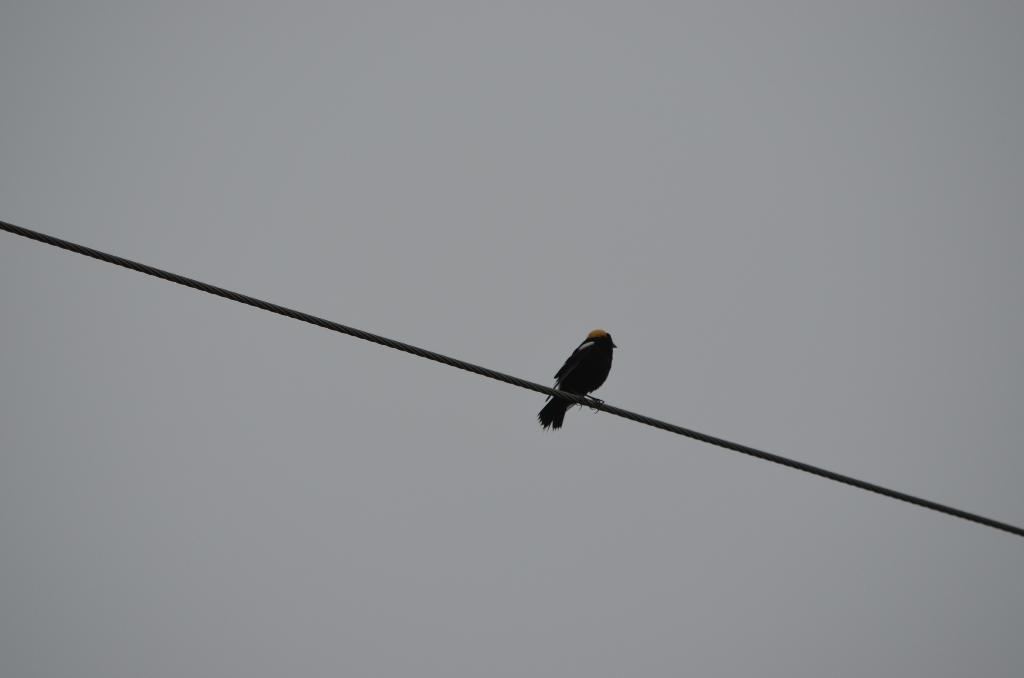What type of animal can be seen in the image? There is a bird in the image. Where is the bird located? The bird is on a wire. What can be seen in the background of the image? There is sky visible in the background of the image. What card is the bird holding in its beak in the image? There is no card present in the image; the bird is on a wire and there is sky visible in the background. 